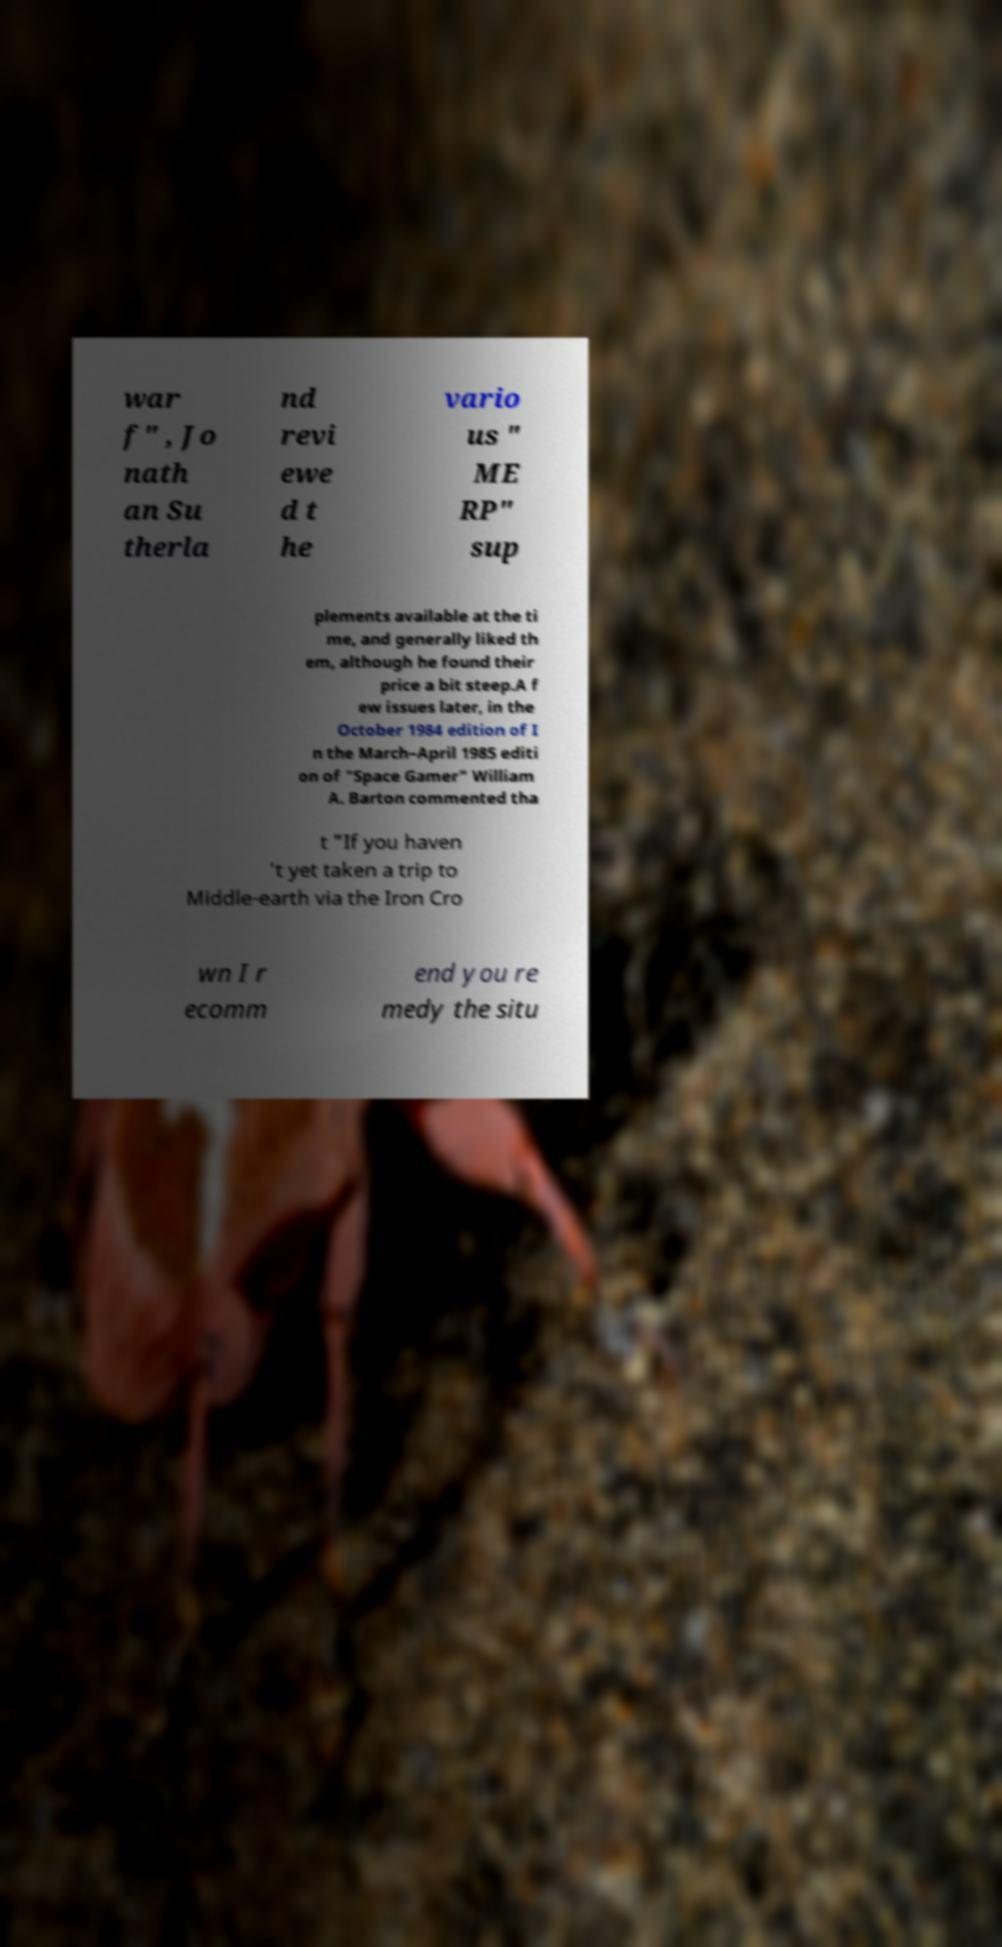Please identify and transcribe the text found in this image. war f" , Jo nath an Su therla nd revi ewe d t he vario us " ME RP" sup plements available at the ti me, and generally liked th em, although he found their price a bit steep.A f ew issues later, in the October 1984 edition of I n the March–April 1985 editi on of "Space Gamer" William A. Barton commented tha t "If you haven 't yet taken a trip to Middle-earth via the Iron Cro wn I r ecomm end you re medy the situ 